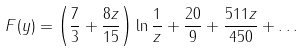Convert formula to latex. <formula><loc_0><loc_0><loc_500><loc_500>F ( y ) = \left ( \frac { 7 } { 3 } + \frac { 8 z } { 1 5 } \right ) \ln \frac { 1 } { z } + \frac { 2 0 } { 9 } + \frac { 5 1 1 z } { 4 5 0 } + \dots</formula> 